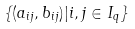<formula> <loc_0><loc_0><loc_500><loc_500>\left \{ ( a _ { i j } , b _ { i j } ) | i , j \in I _ { q } \right \}</formula> 